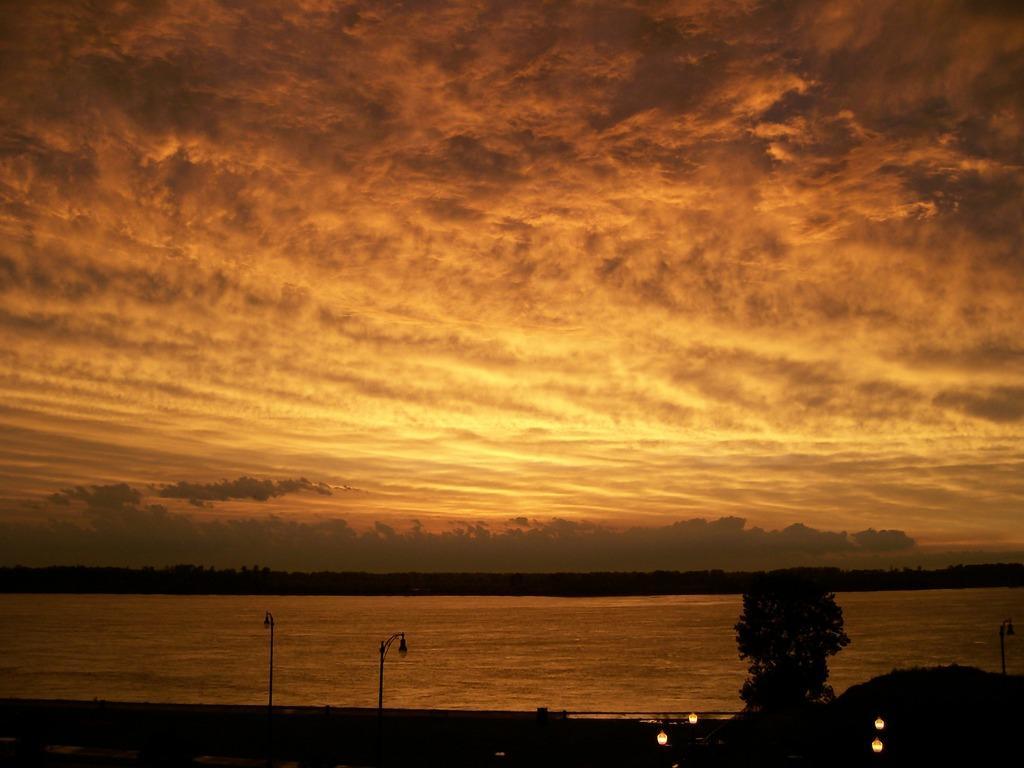Please provide a concise description of this image. In this image there is a road with lamps, in the background there is a river, trees and the sky. 